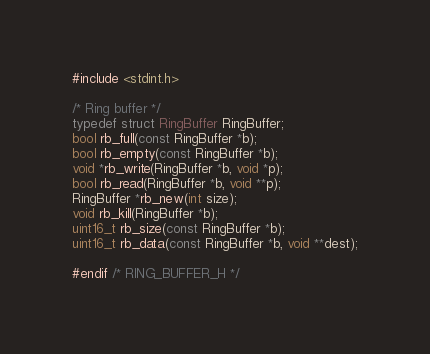Convert code to text. <code><loc_0><loc_0><loc_500><loc_500><_C_>#include <stdint.h>

/* Ring buffer */
typedef struct RingBuffer RingBuffer;
bool rb_full(const RingBuffer *b);
bool rb_empty(const RingBuffer *b);
void *rb_write(RingBuffer *b, void *p);
bool rb_read(RingBuffer *b, void **p);
RingBuffer *rb_new(int size);
void rb_kill(RingBuffer *b);
uint16_t rb_size(const RingBuffer *b);
uint16_t rb_data(const RingBuffer *b, void **dest);

#endif /* RING_BUFFER_H */
</code> 